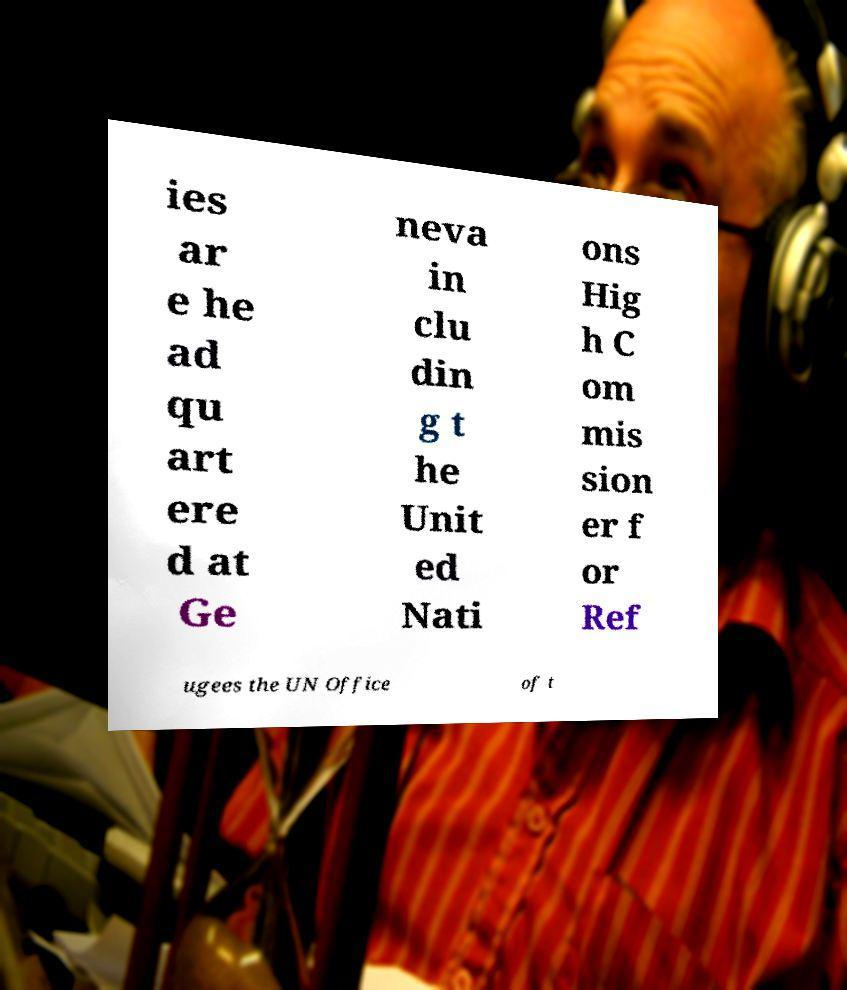Please identify and transcribe the text found in this image. ies ar e he ad qu art ere d at Ge neva in clu din g t he Unit ed Nati ons Hig h C om mis sion er f or Ref ugees the UN Office of t 